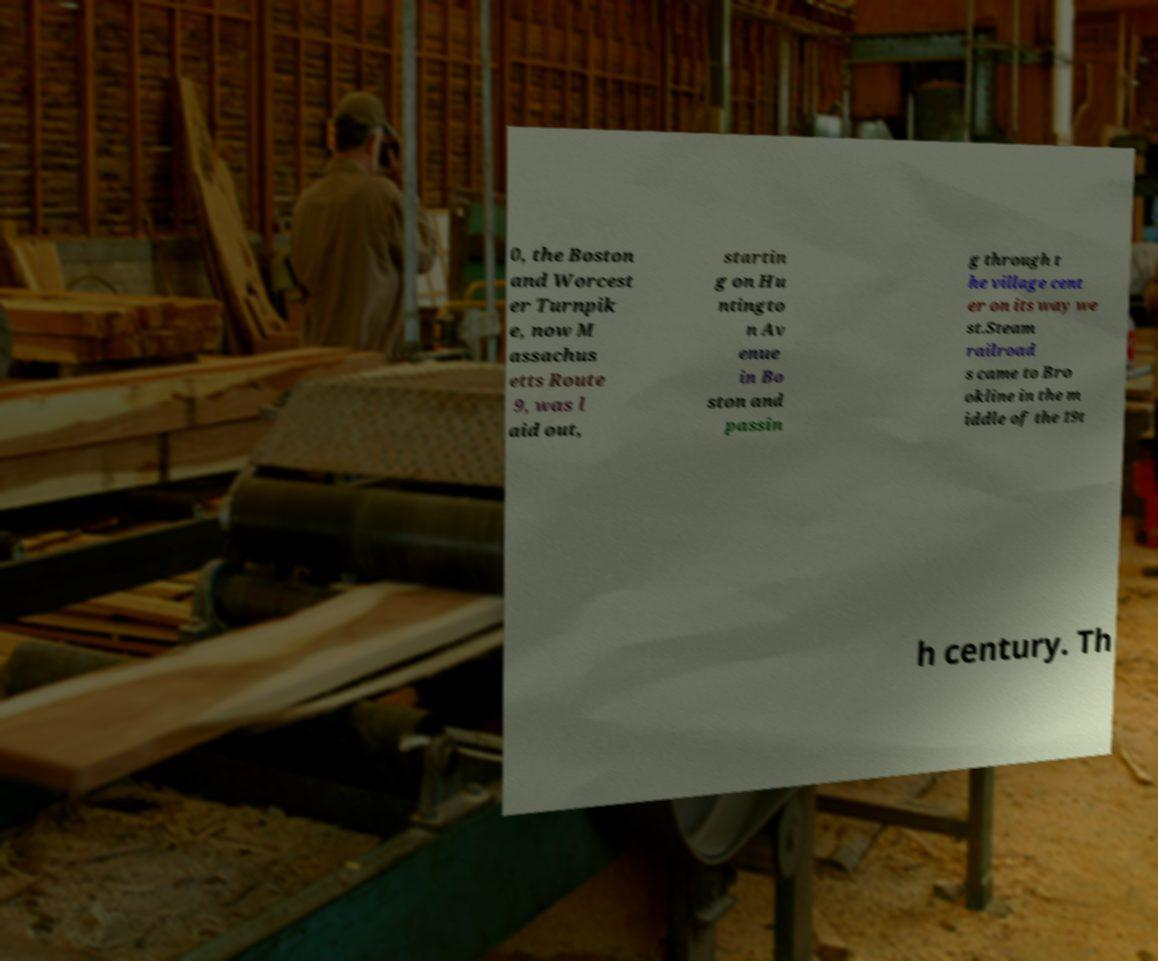Please identify and transcribe the text found in this image. 0, the Boston and Worcest er Turnpik e, now M assachus etts Route 9, was l aid out, startin g on Hu ntingto n Av enue in Bo ston and passin g through t he village cent er on its way we st.Steam railroad s came to Bro okline in the m iddle of the 19t h century. Th 